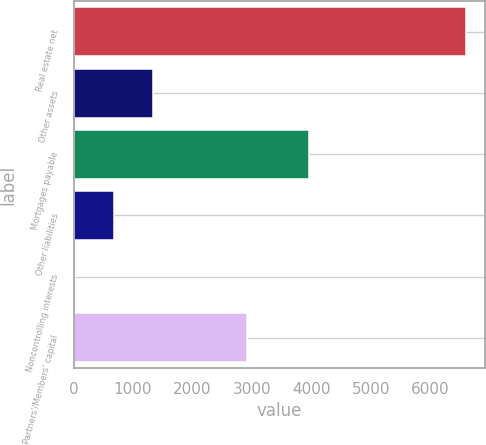<chart> <loc_0><loc_0><loc_500><loc_500><bar_chart><fcel>Real estate net<fcel>Other assets<fcel>Mortgages payable<fcel>Other liabilities<fcel>Noncontrolling interests<fcel>Partners'/Members' capital<nl><fcel>6601.8<fcel>1335.72<fcel>3956.2<fcel>677.46<fcel>19.2<fcel>2914.5<nl></chart> 